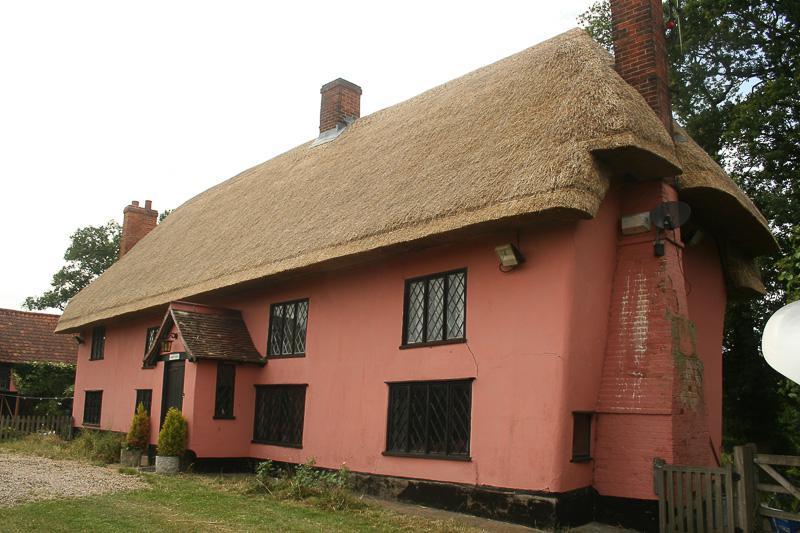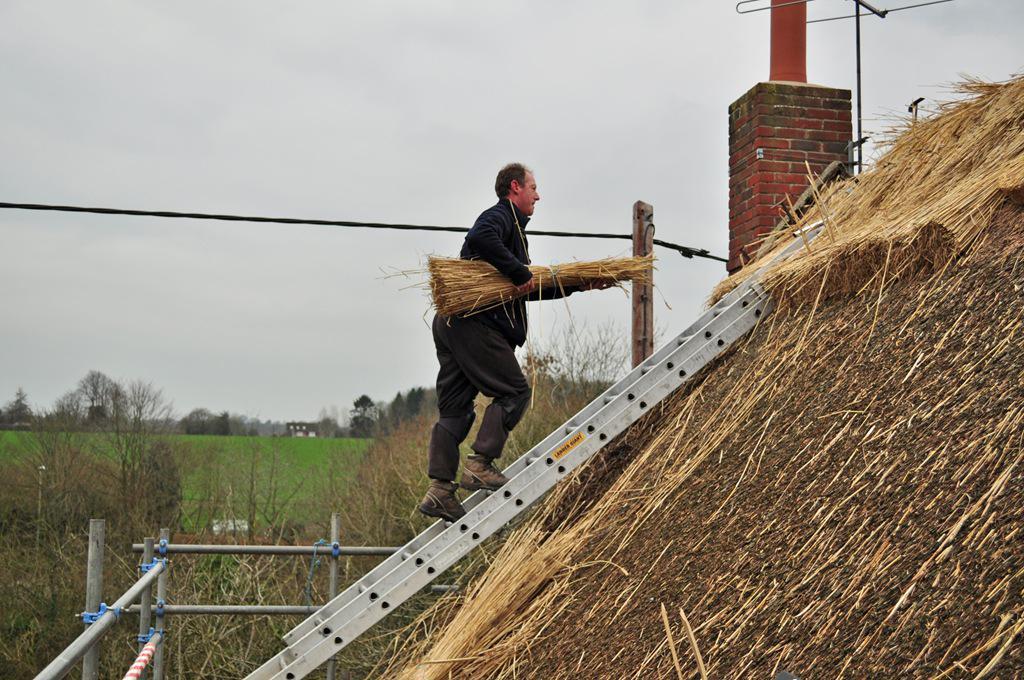The first image is the image on the left, the second image is the image on the right. Given the left and right images, does the statement "Men are repairing a roof." hold true? Answer yes or no. Yes. The first image is the image on the left, the second image is the image on the right. For the images shown, is this caption "At least one man is standing on a ladder propped against an unfinished thatched roof." true? Answer yes or no. Yes. 